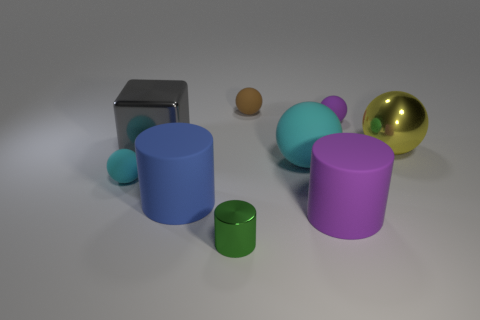Subtract all purple matte balls. How many balls are left? 4 Subtract all cyan spheres. How many spheres are left? 3 Add 1 rubber objects. How many objects exist? 10 Subtract all purple spheres. Subtract all brown cubes. How many spheres are left? 4 Subtract all cubes. How many objects are left? 8 Subtract 1 gray blocks. How many objects are left? 8 Subtract all matte objects. Subtract all small cyan spheres. How many objects are left? 2 Add 9 metallic cylinders. How many metallic cylinders are left? 10 Add 9 big matte spheres. How many big matte spheres exist? 10 